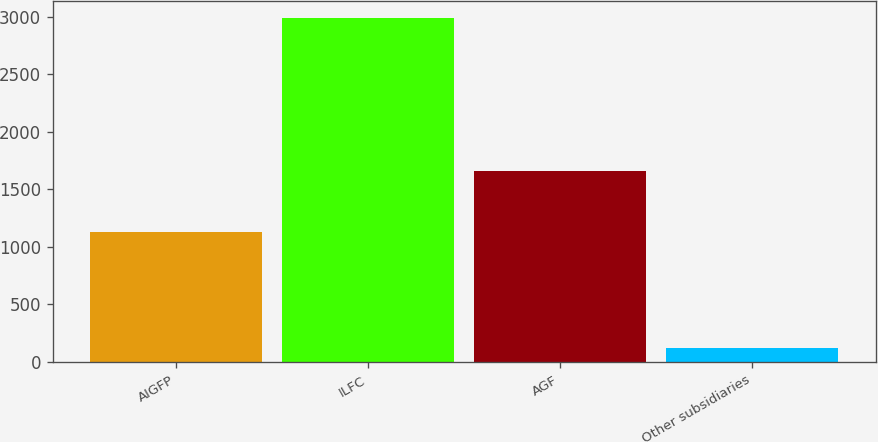<chart> <loc_0><loc_0><loc_500><loc_500><bar_chart><fcel>AIGFP<fcel>ILFC<fcel>AGF<fcel>Other subsidiaries<nl><fcel>1125<fcel>2986<fcel>1661<fcel>124<nl></chart> 